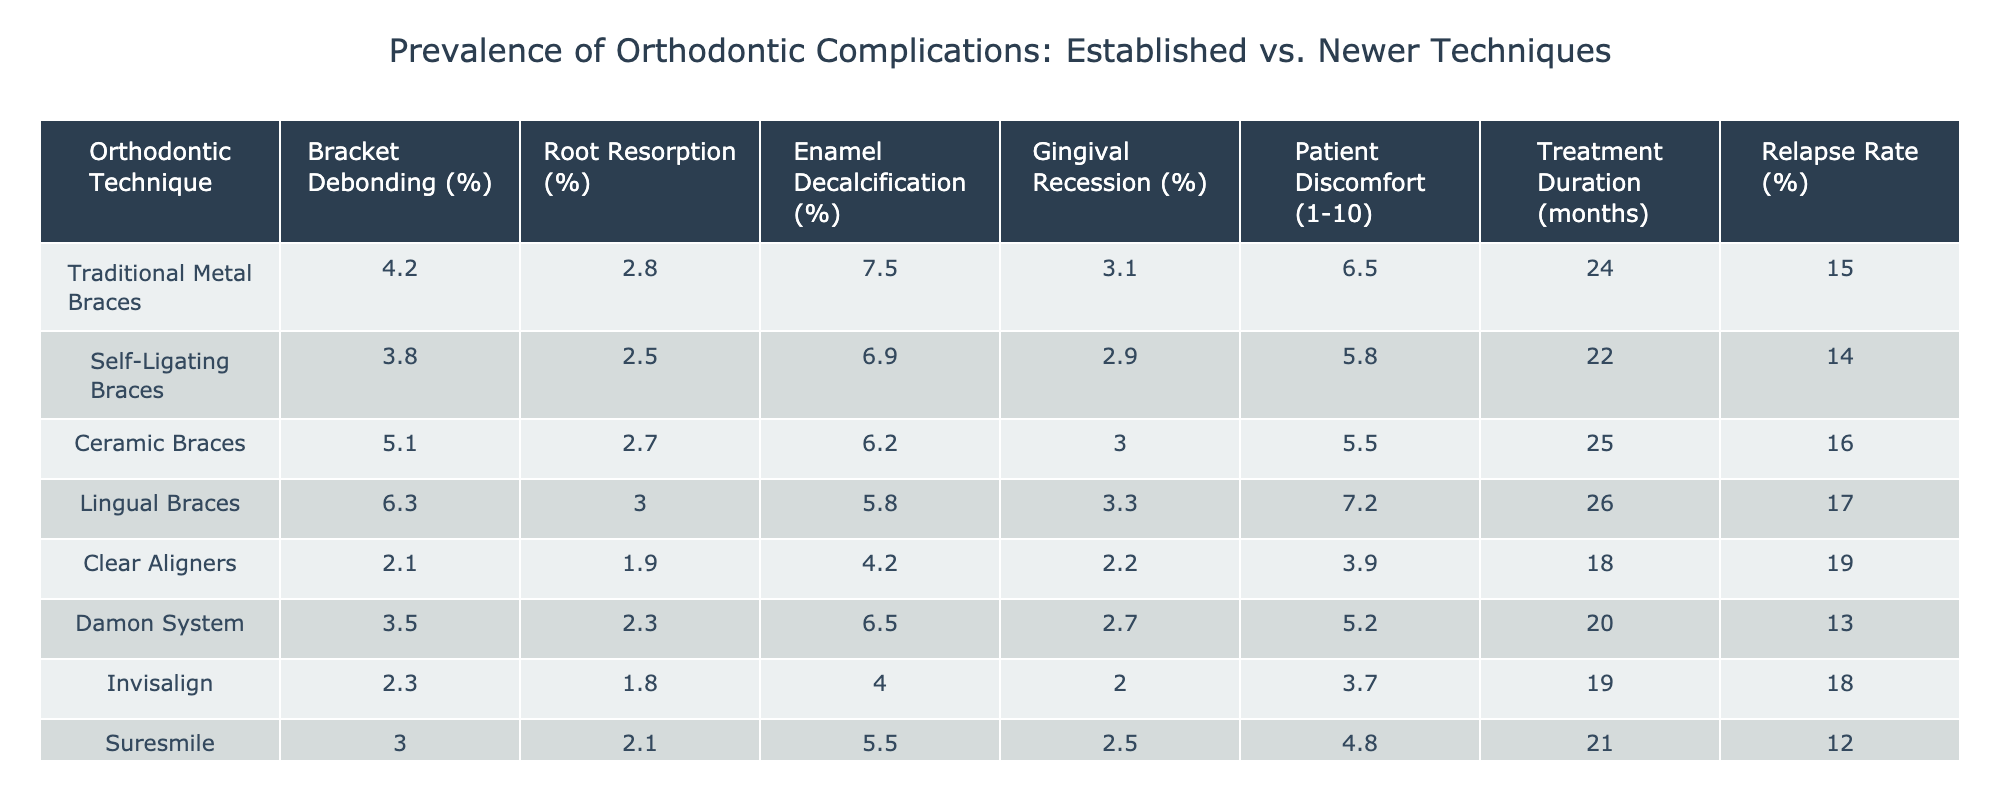What is the percentage of bracket debonding for clear aligners? The table shows that the percentage of bracket debonding for clear aligners is listed directly under the "Bracket Debonding (%)" column. For clear aligners, this value is 2.1%.
Answer: 2.1% Which technique has the highest percentage of root resorption? By looking at the "Root Resorption (%)" column, we can compare the values. The highest percentage is 6.3% for lingual braces.
Answer: 6.3% What is the average patient discomfort score for traditional metal braces and ceramic braces? The discomfort scores for traditional metal braces and ceramic braces are 6.5 and 5.5 respectively. Adding these together gives 12, and dividing by 2 provides the average: 12/2 = 6.
Answer: 6 Is the relapse rate for self-ligating braces lower than that for traditional metal braces? The relapse rates are 14% for self-ligating braces and 15% for traditional metal braces. Since 14% is lower than 15%, the answer is yes.
Answer: Yes How much higher is the percentage of enamel decalcification for ceramic braces compared to clear aligners? The percentage of enamel decalcification is 6.2% for ceramic braces and 4.2% for clear aligners. Subtracting these values gives 6.2% - 4.2% = 2%.
Answer: 2% Which orthodontic technique has the longest treatment duration? By examining the "Treatment Duration (months)" column, we can see that lingual braces have the longest treatment duration at 26 months.
Answer: 26 months What is the total percentage of patient discomfort for traditional metal braces and lingual braces combined? The patient discomfort scores for traditional metal braces and lingual braces are 6.5 and 7.2. Adding these gives 6.5 + 7.2 = 13.7.
Answer: 13.7 Does the Damon system have a higher patient discomfort score than the Suresmile technique? The patient discomfort score for the Damon system is 5.2 and for the Suresmile, it is 4.8. Since 5.2 is greater than 4.8, the answer is yes.
Answer: Yes What is the difference in the percentage of gingival recession between ceramic braces and clear aligners? The percentage of gingival recession for ceramic braces is 3.0% and for clear aligners is 2.2%. Subtracting these gives 3.0% - 2.2% = 0.8%.
Answer: 0.8% Calculate the average relapse rate for all techniques listed in the table. The relapse rates are 15, 14, 16, 17, 19, 13, 18, and 12. Adding these gives a total of 124. There are 8 techniques, so the average is 124/8 = 15.5.
Answer: 15.5 